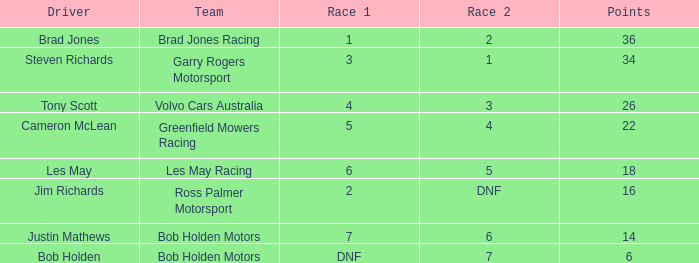Among bob holden motors' drivers, who has under 36 points and came in 7th place during the initial race? Justin Mathews. 